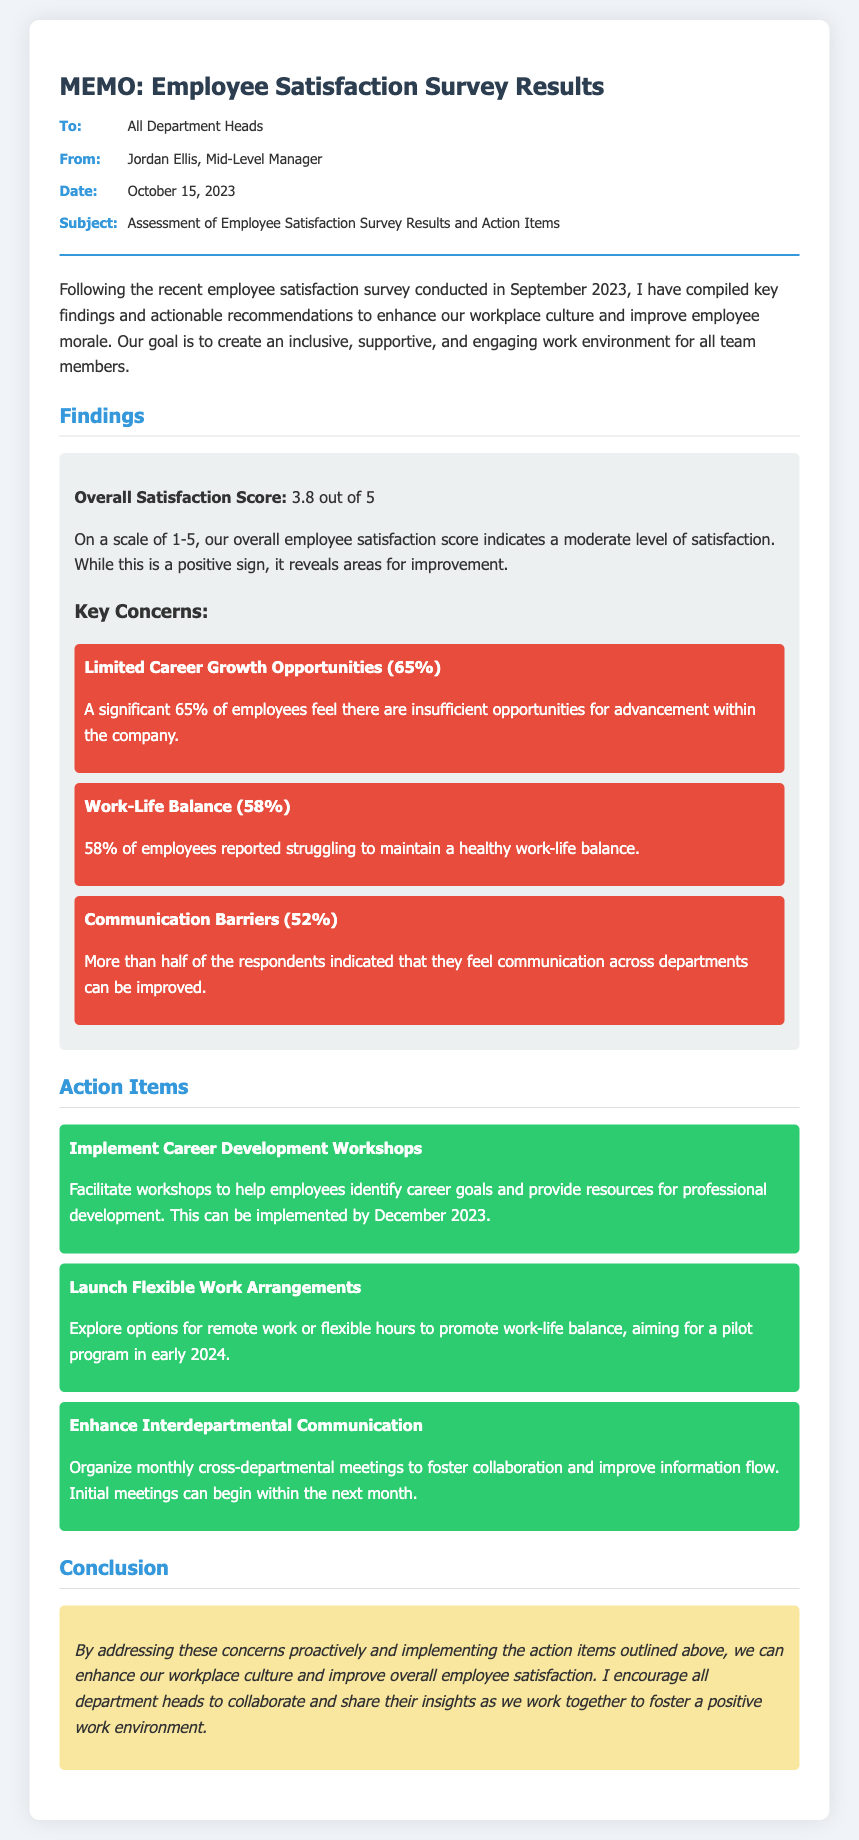What is the overall satisfaction score? The overall satisfaction score is mentioned in the findings section of the memo as being 3.8 out of 5.
Answer: 3.8 out of 5 What percentage of employees feel there are limited career growth opportunities? The memo indicates that 65% of employees feel there are insufficient opportunities for advancement.
Answer: 65% When was the employee satisfaction survey conducted? The survey was conducted in September 2023, as noted in the introduction.
Answer: September 2023 What action item is suggested to improve career development? It suggests implementing career development workshops to help employees identify career goals.
Answer: Implement Career Development Workshops What percentage of employees reported struggling with work-life balance? The memo states that 58% of employees reported this concern regarding work-life balance.
Answer: 58% What is the purpose of enhancing interdepartmental communication? The reasoning for enhancing communication is to improve collaboration and information flow across departments.
Answer: Improve collaboration and information flow When is the initial meeting for enhancing interdepartmental communication planned to begin? The memo suggests that the initial meetings can begin within the next month.
Answer: Within the next month What date is the memo dated? The date of the memo is specifically mentioned in the meta section.
Answer: October 15, 2023 What creates a moderate level of satisfaction according to the memo? The moderate level of satisfaction is indicated by the overall satisfaction score of 3.8 out of 5.
Answer: 3.8 out of 5 